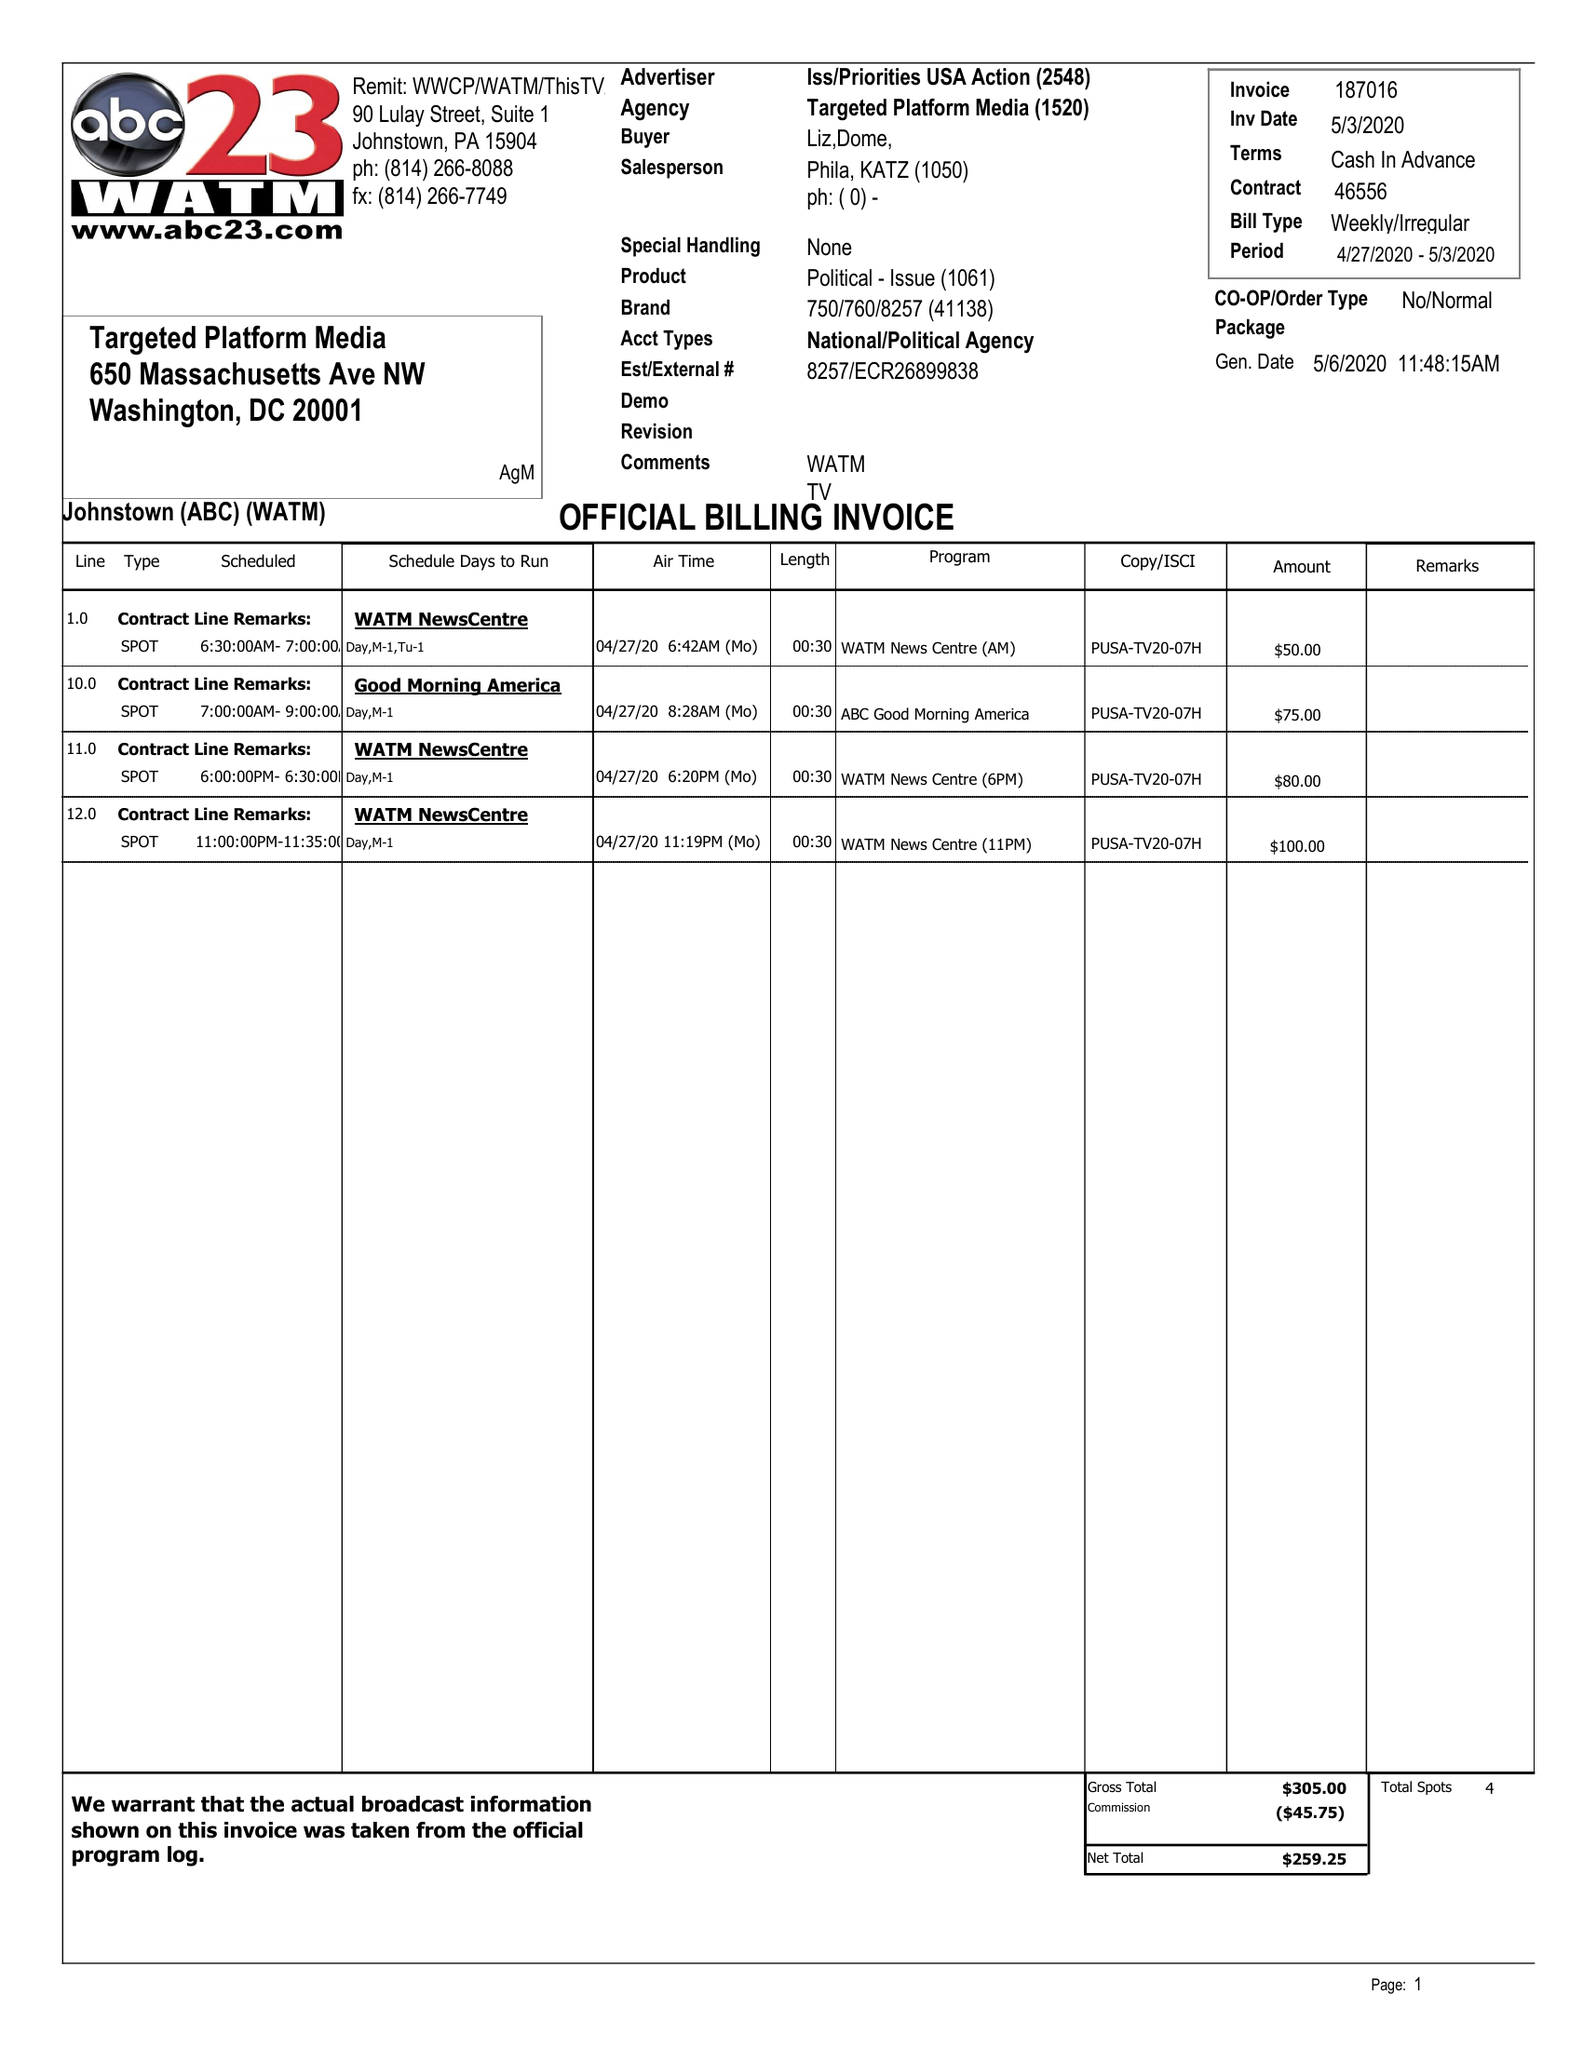What is the value for the advertiser?
Answer the question using a single word or phrase. ISS/PRIORITIESUSAACTION 